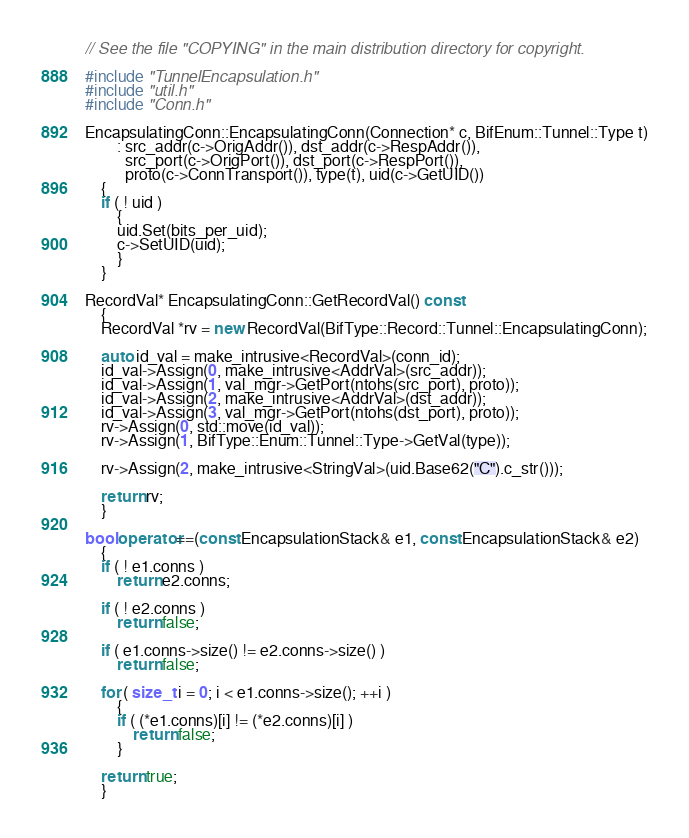<code> <loc_0><loc_0><loc_500><loc_500><_C++_>// See the file "COPYING" in the main distribution directory for copyright.

#include "TunnelEncapsulation.h"
#include "util.h"
#include "Conn.h"

EncapsulatingConn::EncapsulatingConn(Connection* c, BifEnum::Tunnel::Type t)
		: src_addr(c->OrigAddr()), dst_addr(c->RespAddr()),
		  src_port(c->OrigPort()), dst_port(c->RespPort()),
		  proto(c->ConnTransport()), type(t), uid(c->GetUID())
	{
	if ( ! uid )
		{
		uid.Set(bits_per_uid);
		c->SetUID(uid);
		}
	}

RecordVal* EncapsulatingConn::GetRecordVal() const
	{
	RecordVal *rv = new RecordVal(BifType::Record::Tunnel::EncapsulatingConn);

	auto id_val = make_intrusive<RecordVal>(conn_id);
	id_val->Assign(0, make_intrusive<AddrVal>(src_addr));
	id_val->Assign(1, val_mgr->GetPort(ntohs(src_port), proto));
	id_val->Assign(2, make_intrusive<AddrVal>(dst_addr));
	id_val->Assign(3, val_mgr->GetPort(ntohs(dst_port), proto));
	rv->Assign(0, std::move(id_val));
	rv->Assign(1, BifType::Enum::Tunnel::Type->GetVal(type));

	rv->Assign(2, make_intrusive<StringVal>(uid.Base62("C").c_str()));

	return rv;
	}

bool operator==(const EncapsulationStack& e1, const EncapsulationStack& e2)
	{
	if ( ! e1.conns )
		return e2.conns;

	if ( ! e2.conns )
		return false;

	if ( e1.conns->size() != e2.conns->size() )
		return false;

	for ( size_t i = 0; i < e1.conns->size(); ++i )
		{
		if ( (*e1.conns)[i] != (*e2.conns)[i] )
			return false;
		}

	return true;
	}
</code> 